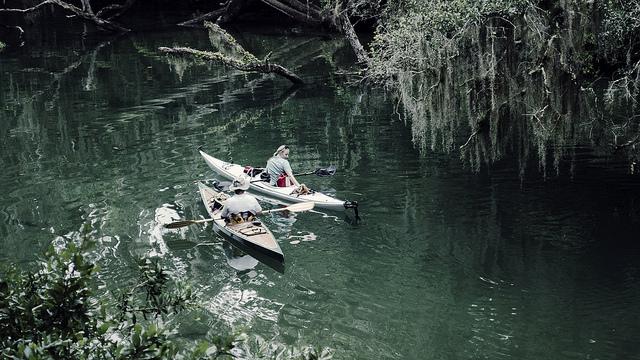How many boats?
Quick response, please. 2. Is this an ocean?
Give a very brief answer. No. How many humans are there?
Write a very short answer. 2. 